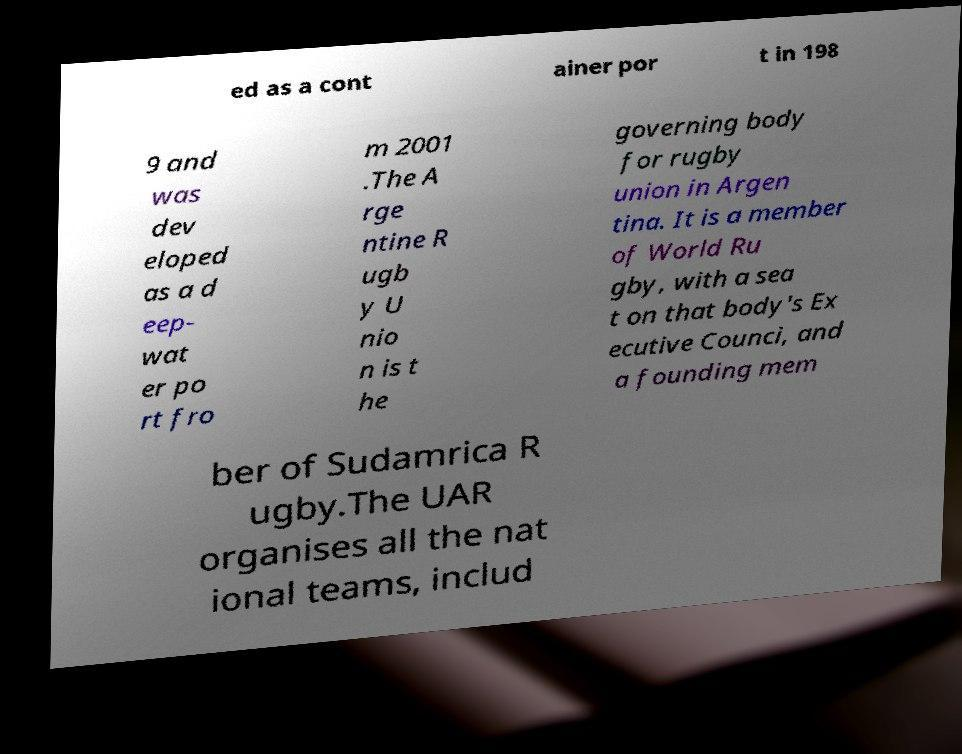What messages or text are displayed in this image? I need them in a readable, typed format. ed as a cont ainer por t in 198 9 and was dev eloped as a d eep- wat er po rt fro m 2001 .The A rge ntine R ugb y U nio n is t he governing body for rugby union in Argen tina. It is a member of World Ru gby, with a sea t on that body's Ex ecutive Counci, and a founding mem ber of Sudamrica R ugby.The UAR organises all the nat ional teams, includ 